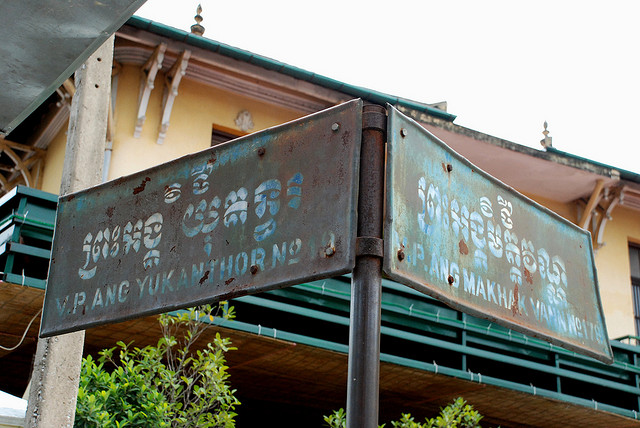<image>What does the sign say? I don't know what the sign says. It can be 'vp ang yukamthorne', 'yp ang yukanthorn0', 'welcome aboard', 'market', 'vp ang yukanthor no 19', 'streets', or 'vp ang yukanthor'. What does the sign say? I cannot determine what the sign says. It is unclear. 